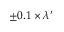<formula> <loc_0><loc_0><loc_500><loc_500>\pm 0 . 1 \times \lambda ^ { \prime }</formula> 